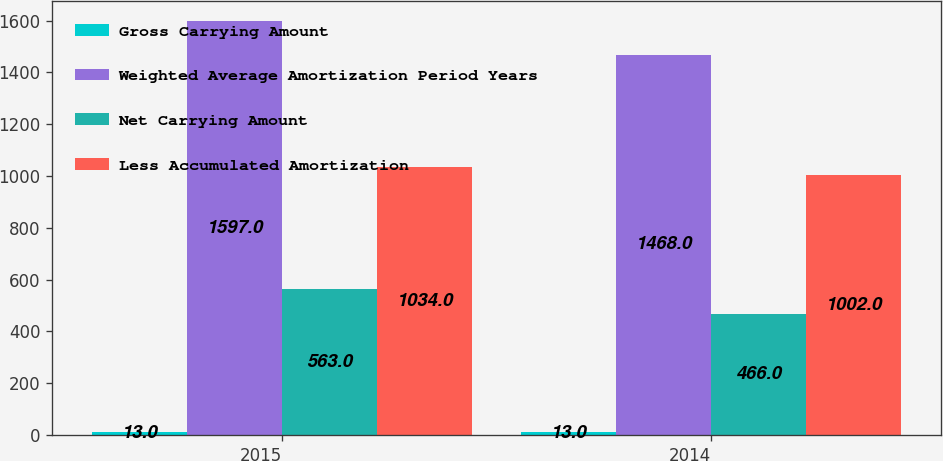Convert chart to OTSL. <chart><loc_0><loc_0><loc_500><loc_500><stacked_bar_chart><ecel><fcel>2015<fcel>2014<nl><fcel>Gross Carrying Amount<fcel>13<fcel>13<nl><fcel>Weighted Average Amortization Period Years<fcel>1597<fcel>1468<nl><fcel>Net Carrying Amount<fcel>563<fcel>466<nl><fcel>Less Accumulated Amortization<fcel>1034<fcel>1002<nl></chart> 